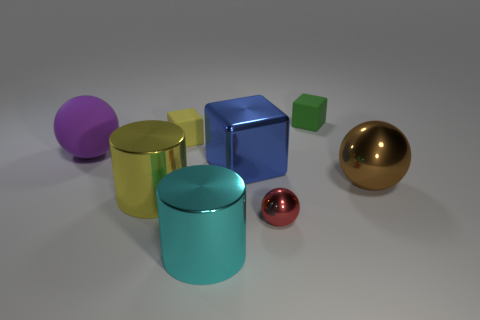What number of tiny things are in front of the green object and behind the large shiny sphere?
Give a very brief answer. 1. Are there fewer big cylinders that are in front of the rubber sphere than cyan cylinders behind the yellow matte block?
Keep it short and to the point. No. Is the small red thing the same shape as the small green matte object?
Provide a succinct answer. No. How many other things are the same size as the red thing?
Ensure brevity in your answer.  2. How many objects are small matte cubes to the left of the large cyan thing or large metal objects to the right of the big shiny block?
Ensure brevity in your answer.  2. What number of small yellow rubber things have the same shape as the tiny green object?
Your answer should be compact. 1. There is a big object that is in front of the large brown thing and behind the tiny red metal ball; what is its material?
Offer a very short reply. Metal. There is a tiny red shiny sphere; what number of rubber spheres are behind it?
Provide a succinct answer. 1. How many large green shiny cylinders are there?
Your response must be concise. 0. Is the size of the cyan shiny thing the same as the green cube?
Provide a succinct answer. No. 